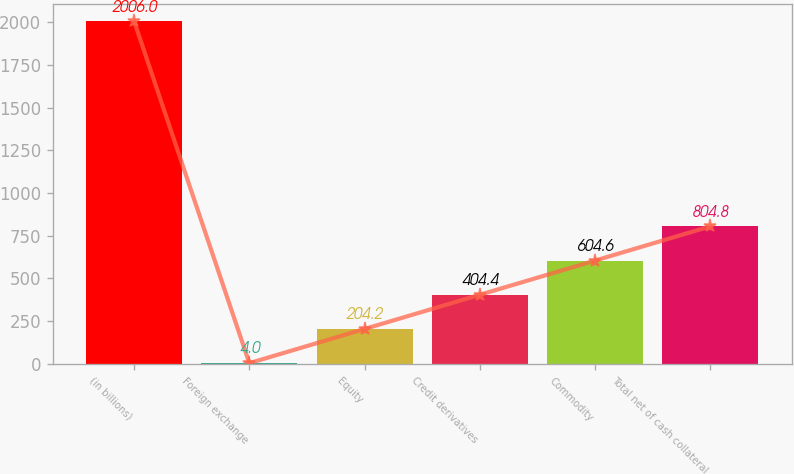<chart> <loc_0><loc_0><loc_500><loc_500><bar_chart><fcel>(in billions)<fcel>Foreign exchange<fcel>Equity<fcel>Credit derivatives<fcel>Commodity<fcel>Total net of cash collateral<nl><fcel>2006<fcel>4<fcel>204.2<fcel>404.4<fcel>604.6<fcel>804.8<nl></chart> 